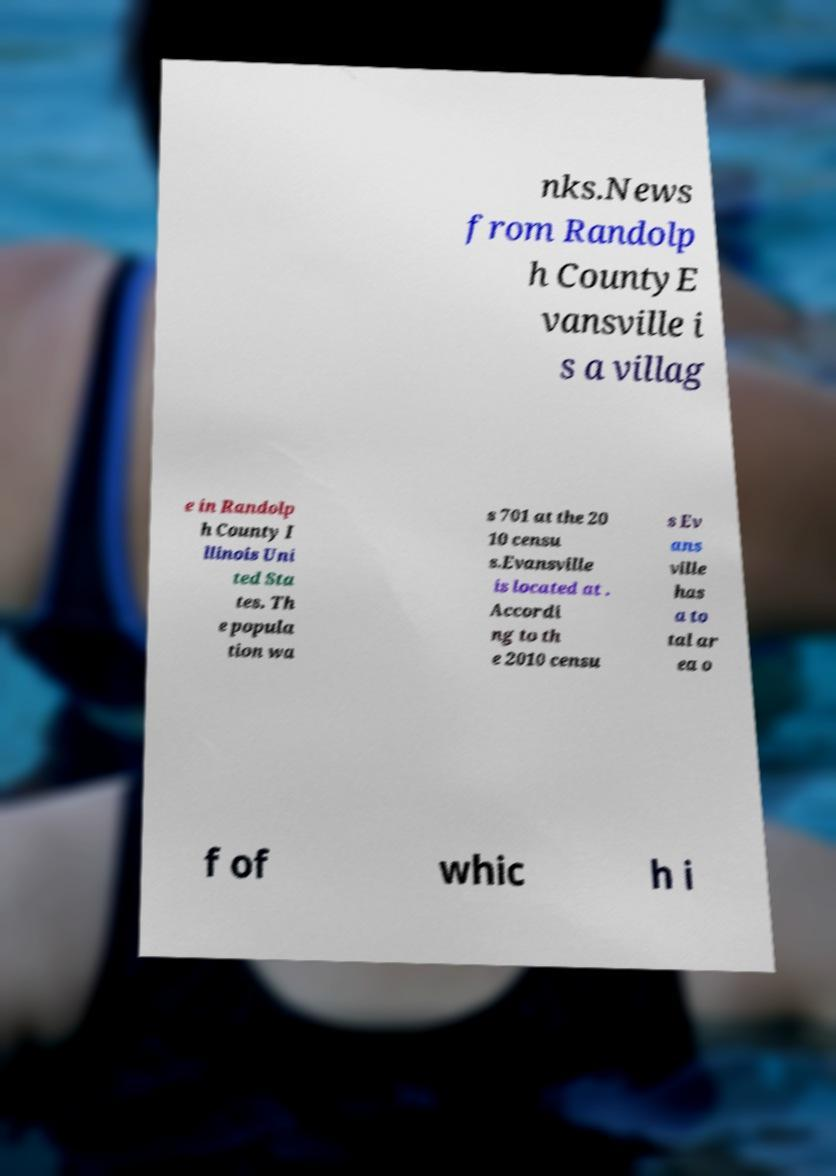Can you accurately transcribe the text from the provided image for me? nks.News from Randolp h CountyE vansville i s a villag e in Randolp h County I llinois Uni ted Sta tes. Th e popula tion wa s 701 at the 20 10 censu s.Evansville is located at . Accordi ng to th e 2010 censu s Ev ans ville has a to tal ar ea o f of whic h i 